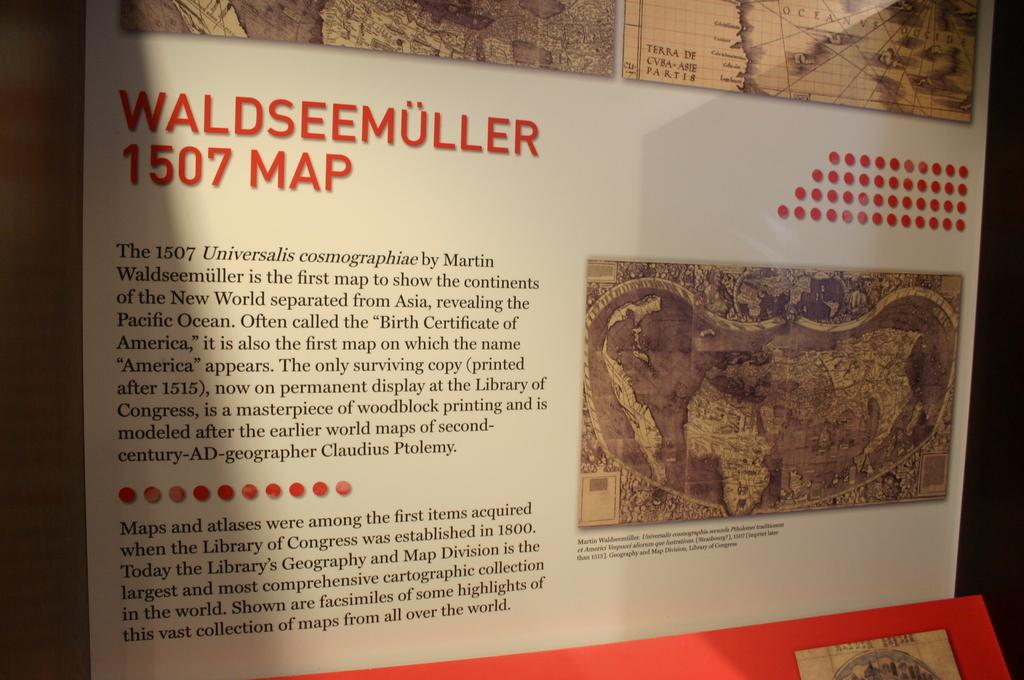<image>
Share a concise interpretation of the image provided. A display board features a 1507 map of Waldseemuller 